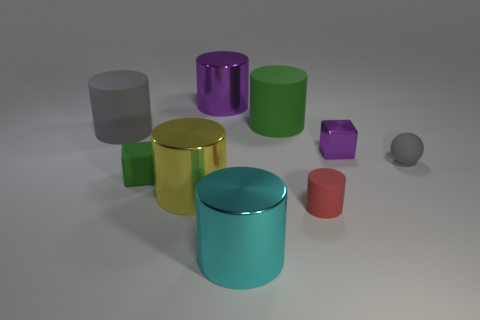How many tiny red matte cylinders are there?
Provide a short and direct response. 1. What number of objects are yellow metal objects or matte cylinders right of the big purple cylinder?
Your answer should be very brief. 3. Are there any other things that are the same shape as the small red object?
Give a very brief answer. Yes. There is a gray matte thing left of the rubber sphere; is it the same size as the big purple metallic cylinder?
Offer a terse response. Yes. What number of matte objects are red objects or tiny green cubes?
Keep it short and to the point. 2. There is a gray thing that is to the right of the gray cylinder; what is its size?
Provide a short and direct response. Small. Are there an equal number of red rubber things and big red objects?
Offer a very short reply. No. Is the cyan metal thing the same shape as the yellow metal object?
Offer a terse response. Yes. What number of large things are either gray spheres or gray matte blocks?
Keep it short and to the point. 0. Are there any big green cylinders to the right of the ball?
Give a very brief answer. No. 